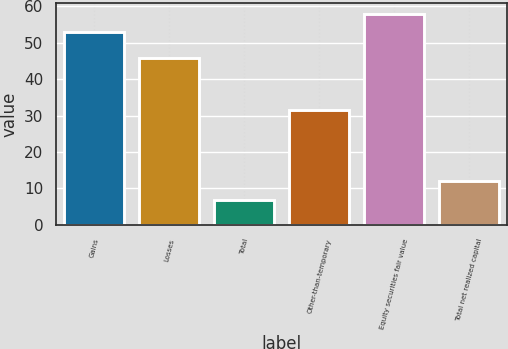<chart> <loc_0><loc_0><loc_500><loc_500><bar_chart><fcel>Gains<fcel>Losses<fcel>Total<fcel>Other-than-temporary<fcel>Equity securities fair value<fcel>Total net realized capital<nl><fcel>52.8<fcel>45.9<fcel>6.9<fcel>31.6<fcel>57.88<fcel>11.98<nl></chart> 